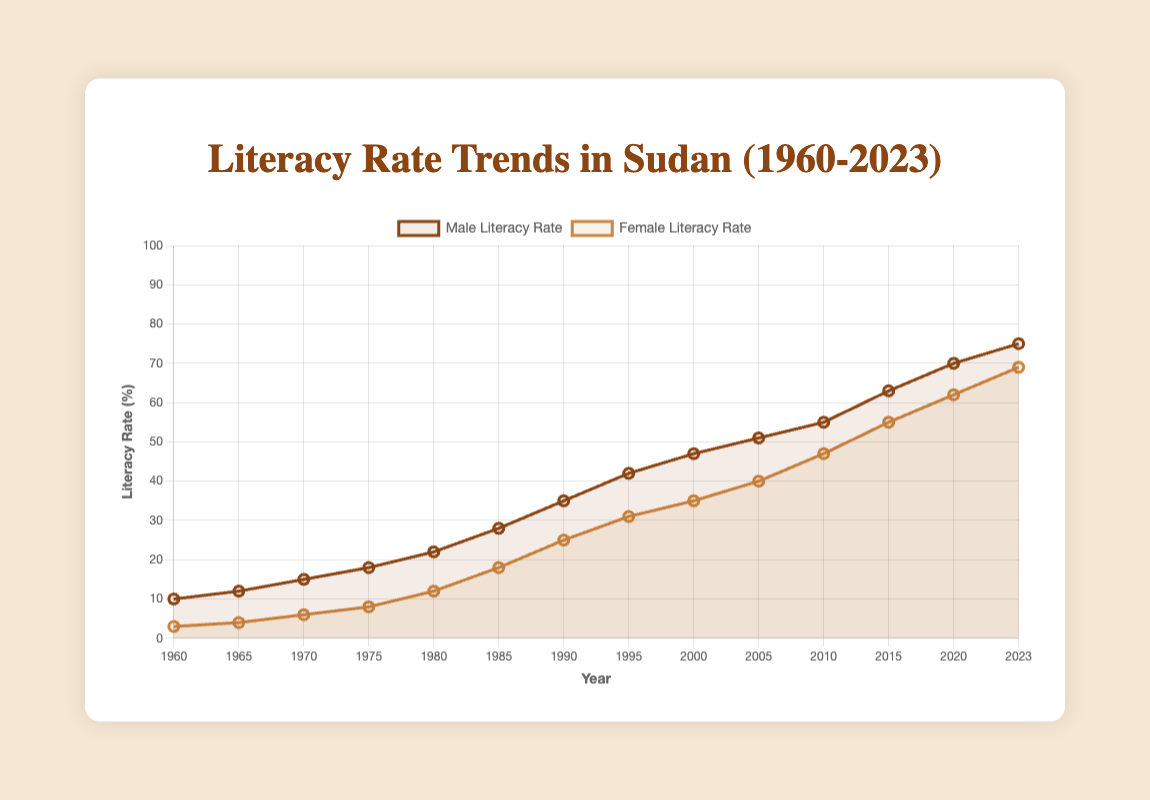What is the average male literacy rate from 1960 to 2023? To find the average male literacy rate, sum all the literacy rates from 1960 to 2023 and divide by the number of years (14). The total is 543, and 543 divided by 14 is approximately 38.79.
Answer: 38.79 By how many percentage points did the female literacy rate increase between 1960 and 2023? Subtract the female literacy rate in 1960 from the rate in 2023. The difference is 69 - 3, which equals 66 percentage points.
Answer: 66 In 1975, was the male literacy rate higher than the female literacy rate? If so, by how much? In 1975, the male literacy rate was 18% and the female literacy rate was 8%. The difference is 18 - 8, which equals 10 percentage points.
Answer: 10 Compare the literacy rates in 1980: Is the gap between male and female literacy rates narrowing compared to 1960? In 1960, the male literacy rate was 10% and the female literacy rate was 3%, a gap of 7 percentage points. In 1980, the male literacy rate was 22% and the female literacy rate was 12%, a gap of 10 percentage points. The gap widened in 1980 compared to 1960.
Answer: No, the gap widened Which gender had a higher literacy rate in 2020 and by how many percentage points? In 2020, the male literacy rate was 70% and the female literacy rate was 62%. The difference is 70 - 62, which equals 8 percentage points.
Answer: Male by 8 What is the trend in female literacy rates from 1960 to 2023? To describe the trend, note that the female literacy rate steadily increased from 3% in 1960 to 69% in 2023. This indicates a positive, upward trend in female literacy.
Answer: Increasing How do the male and female literacy rates compare in 2000? In 2000, the male literacy rate was 47% and the female literacy rate was 35%. This means the male literacy rate was 12 percentage points higher than the female literacy rate.
Answer: Male by 12 Between which two consecutive years did the male literacy rate increase the most? By checking the differences between consecutive years, the largest increase for males occurred between 1980 and 1985, where the literacy rate increased by 6 percentage points (from 22% to 28%).
Answer: 1980-1985 What was the male literacy rate in 1995? Look at the data for the male literacy rate in 1995, which shows it was 42%.
Answer: 42 What can be inferred about the overall literacy rate trends for both genders from 1960 to 2023? Overall, both male and female literacy rates have shown significant positive growth from 1960 to 2023. Male literacy went from 10% to 75%, while female literacy went from 3% to 69%, showing a narrowing gender gap over time.
Answer: Increased 